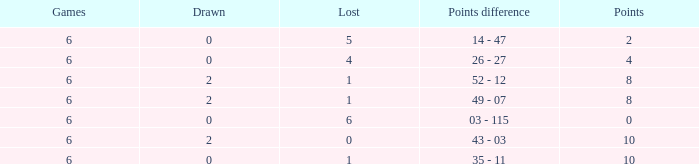What was the highest points where there were less than 2 drawn and the games were less than 6? None. 